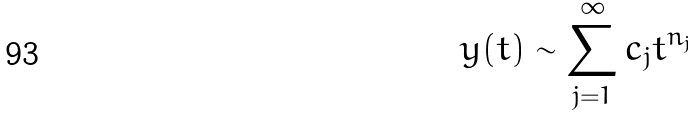Convert formula to latex. <formula><loc_0><loc_0><loc_500><loc_500>y ( t ) \sim \sum _ { j = 1 } ^ { \infty } c _ { j } t ^ { n _ { j } }</formula> 